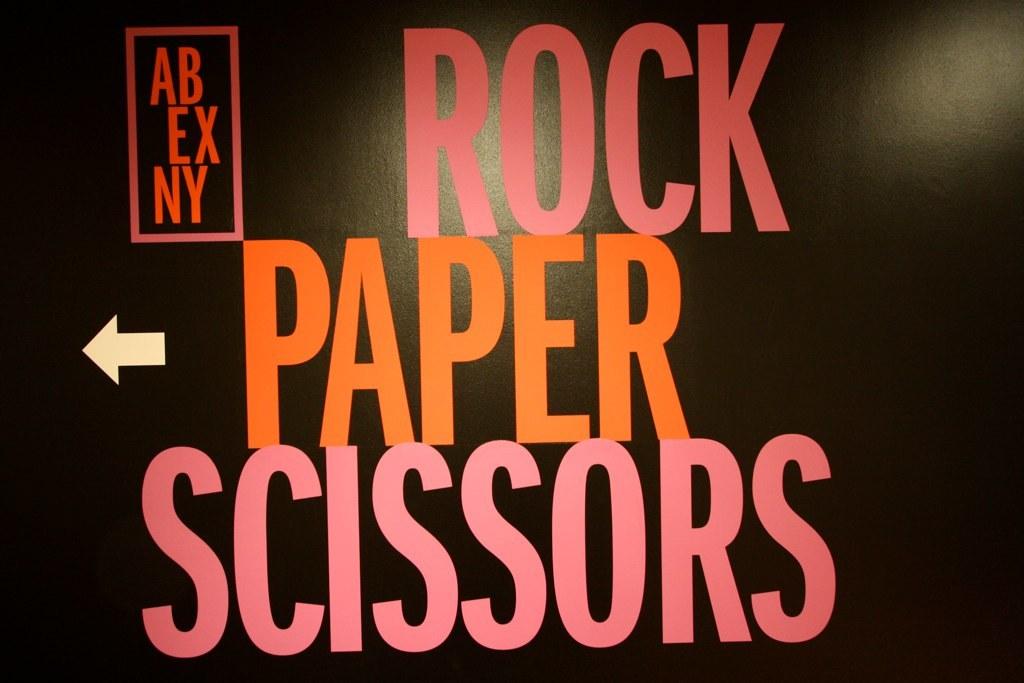What is the name of this event?
Provide a succinct answer. Rock paper scissors. What type of game is this?
Offer a terse response. Rock paper scissors. 